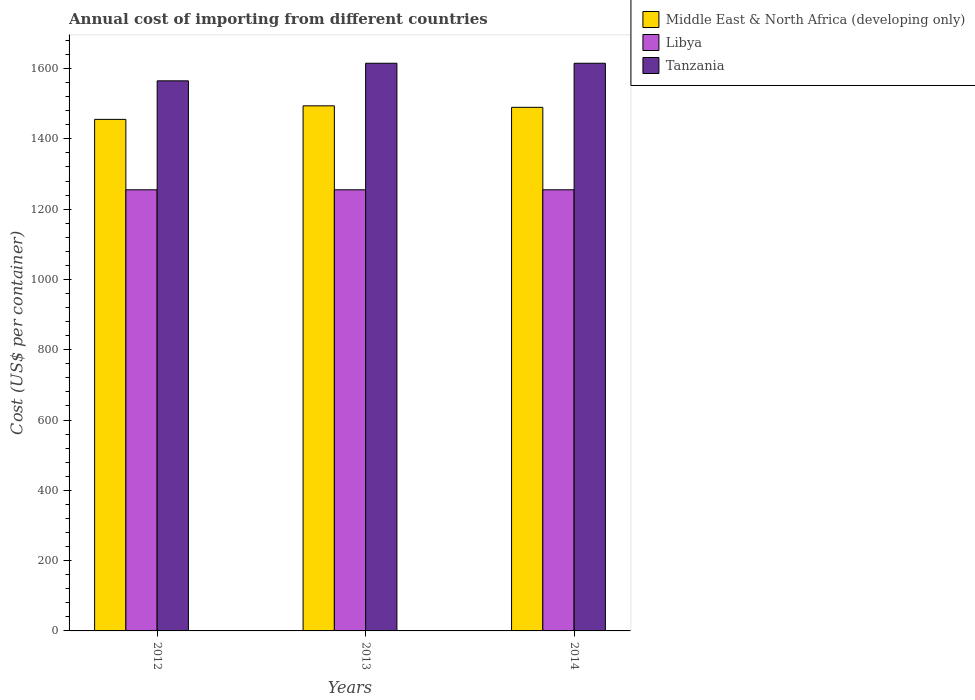How many different coloured bars are there?
Offer a very short reply. 3. How many groups of bars are there?
Make the answer very short. 3. How many bars are there on the 1st tick from the left?
Offer a terse response. 3. What is the total annual cost of importing in Middle East & North Africa (developing only) in 2014?
Ensure brevity in your answer.  1489.62. Across all years, what is the maximum total annual cost of importing in Libya?
Offer a very short reply. 1255. Across all years, what is the minimum total annual cost of importing in Middle East & North Africa (developing only)?
Your response must be concise. 1455.31. In which year was the total annual cost of importing in Tanzania maximum?
Your response must be concise. 2013. In which year was the total annual cost of importing in Tanzania minimum?
Offer a terse response. 2012. What is the total total annual cost of importing in Tanzania in the graph?
Make the answer very short. 4795. What is the difference between the total annual cost of importing in Middle East & North Africa (developing only) in 2012 and that in 2013?
Provide a succinct answer. -38.54. What is the difference between the total annual cost of importing in Middle East & North Africa (developing only) in 2014 and the total annual cost of importing in Libya in 2012?
Ensure brevity in your answer.  234.62. What is the average total annual cost of importing in Tanzania per year?
Your response must be concise. 1598.33. In the year 2013, what is the difference between the total annual cost of importing in Middle East & North Africa (developing only) and total annual cost of importing in Tanzania?
Your answer should be very brief. -121.15. What is the ratio of the total annual cost of importing in Libya in 2012 to that in 2013?
Offer a very short reply. 1. Is the difference between the total annual cost of importing in Middle East & North Africa (developing only) in 2012 and 2013 greater than the difference between the total annual cost of importing in Tanzania in 2012 and 2013?
Make the answer very short. Yes. What is the difference between the highest and the second highest total annual cost of importing in Middle East & North Africa (developing only)?
Provide a short and direct response. 4.23. What is the difference between the highest and the lowest total annual cost of importing in Tanzania?
Provide a succinct answer. 50. What does the 3rd bar from the left in 2014 represents?
Your answer should be compact. Tanzania. What does the 2nd bar from the right in 2014 represents?
Ensure brevity in your answer.  Libya. Is it the case that in every year, the sum of the total annual cost of importing in Libya and total annual cost of importing in Middle East & North Africa (developing only) is greater than the total annual cost of importing in Tanzania?
Your answer should be compact. Yes. How many bars are there?
Provide a short and direct response. 9. Are all the bars in the graph horizontal?
Make the answer very short. No. How many years are there in the graph?
Offer a terse response. 3. What is the difference between two consecutive major ticks on the Y-axis?
Offer a very short reply. 200. Does the graph contain grids?
Provide a succinct answer. No. Where does the legend appear in the graph?
Your response must be concise. Top right. How many legend labels are there?
Keep it short and to the point. 3. How are the legend labels stacked?
Provide a succinct answer. Vertical. What is the title of the graph?
Your answer should be compact. Annual cost of importing from different countries. Does "Arab World" appear as one of the legend labels in the graph?
Your response must be concise. No. What is the label or title of the X-axis?
Provide a succinct answer. Years. What is the label or title of the Y-axis?
Provide a succinct answer. Cost (US$ per container). What is the Cost (US$ per container) of Middle East & North Africa (developing only) in 2012?
Ensure brevity in your answer.  1455.31. What is the Cost (US$ per container) of Libya in 2012?
Offer a very short reply. 1255. What is the Cost (US$ per container) in Tanzania in 2012?
Offer a very short reply. 1565. What is the Cost (US$ per container) of Middle East & North Africa (developing only) in 2013?
Your answer should be compact. 1493.85. What is the Cost (US$ per container) in Libya in 2013?
Your response must be concise. 1255. What is the Cost (US$ per container) of Tanzania in 2013?
Ensure brevity in your answer.  1615. What is the Cost (US$ per container) in Middle East & North Africa (developing only) in 2014?
Your response must be concise. 1489.62. What is the Cost (US$ per container) of Libya in 2014?
Give a very brief answer. 1255. What is the Cost (US$ per container) in Tanzania in 2014?
Your answer should be compact. 1615. Across all years, what is the maximum Cost (US$ per container) of Middle East & North Africa (developing only)?
Offer a very short reply. 1493.85. Across all years, what is the maximum Cost (US$ per container) in Libya?
Give a very brief answer. 1255. Across all years, what is the maximum Cost (US$ per container) of Tanzania?
Offer a terse response. 1615. Across all years, what is the minimum Cost (US$ per container) of Middle East & North Africa (developing only)?
Ensure brevity in your answer.  1455.31. Across all years, what is the minimum Cost (US$ per container) of Libya?
Keep it short and to the point. 1255. Across all years, what is the minimum Cost (US$ per container) in Tanzania?
Give a very brief answer. 1565. What is the total Cost (US$ per container) in Middle East & North Africa (developing only) in the graph?
Provide a short and direct response. 4438.77. What is the total Cost (US$ per container) in Libya in the graph?
Your answer should be very brief. 3765. What is the total Cost (US$ per container) of Tanzania in the graph?
Offer a very short reply. 4795. What is the difference between the Cost (US$ per container) of Middle East & North Africa (developing only) in 2012 and that in 2013?
Keep it short and to the point. -38.54. What is the difference between the Cost (US$ per container) of Libya in 2012 and that in 2013?
Make the answer very short. 0. What is the difference between the Cost (US$ per container) of Tanzania in 2012 and that in 2013?
Keep it short and to the point. -50. What is the difference between the Cost (US$ per container) of Middle East & North Africa (developing only) in 2012 and that in 2014?
Keep it short and to the point. -34.31. What is the difference between the Cost (US$ per container) in Tanzania in 2012 and that in 2014?
Your answer should be compact. -50. What is the difference between the Cost (US$ per container) in Middle East & North Africa (developing only) in 2013 and that in 2014?
Make the answer very short. 4.23. What is the difference between the Cost (US$ per container) of Libya in 2013 and that in 2014?
Give a very brief answer. 0. What is the difference between the Cost (US$ per container) of Middle East & North Africa (developing only) in 2012 and the Cost (US$ per container) of Libya in 2013?
Give a very brief answer. 200.31. What is the difference between the Cost (US$ per container) in Middle East & North Africa (developing only) in 2012 and the Cost (US$ per container) in Tanzania in 2013?
Keep it short and to the point. -159.69. What is the difference between the Cost (US$ per container) of Libya in 2012 and the Cost (US$ per container) of Tanzania in 2013?
Your answer should be very brief. -360. What is the difference between the Cost (US$ per container) of Middle East & North Africa (developing only) in 2012 and the Cost (US$ per container) of Libya in 2014?
Your answer should be compact. 200.31. What is the difference between the Cost (US$ per container) in Middle East & North Africa (developing only) in 2012 and the Cost (US$ per container) in Tanzania in 2014?
Your answer should be very brief. -159.69. What is the difference between the Cost (US$ per container) in Libya in 2012 and the Cost (US$ per container) in Tanzania in 2014?
Offer a very short reply. -360. What is the difference between the Cost (US$ per container) of Middle East & North Africa (developing only) in 2013 and the Cost (US$ per container) of Libya in 2014?
Ensure brevity in your answer.  238.85. What is the difference between the Cost (US$ per container) in Middle East & North Africa (developing only) in 2013 and the Cost (US$ per container) in Tanzania in 2014?
Keep it short and to the point. -121.15. What is the difference between the Cost (US$ per container) in Libya in 2013 and the Cost (US$ per container) in Tanzania in 2014?
Make the answer very short. -360. What is the average Cost (US$ per container) in Middle East & North Africa (developing only) per year?
Provide a succinct answer. 1479.59. What is the average Cost (US$ per container) of Libya per year?
Keep it short and to the point. 1255. What is the average Cost (US$ per container) in Tanzania per year?
Your answer should be compact. 1598.33. In the year 2012, what is the difference between the Cost (US$ per container) of Middle East & North Africa (developing only) and Cost (US$ per container) of Libya?
Provide a succinct answer. 200.31. In the year 2012, what is the difference between the Cost (US$ per container) in Middle East & North Africa (developing only) and Cost (US$ per container) in Tanzania?
Your response must be concise. -109.69. In the year 2012, what is the difference between the Cost (US$ per container) in Libya and Cost (US$ per container) in Tanzania?
Provide a succinct answer. -310. In the year 2013, what is the difference between the Cost (US$ per container) of Middle East & North Africa (developing only) and Cost (US$ per container) of Libya?
Ensure brevity in your answer.  238.85. In the year 2013, what is the difference between the Cost (US$ per container) in Middle East & North Africa (developing only) and Cost (US$ per container) in Tanzania?
Offer a terse response. -121.15. In the year 2013, what is the difference between the Cost (US$ per container) in Libya and Cost (US$ per container) in Tanzania?
Your answer should be compact. -360. In the year 2014, what is the difference between the Cost (US$ per container) in Middle East & North Africa (developing only) and Cost (US$ per container) in Libya?
Your response must be concise. 234.62. In the year 2014, what is the difference between the Cost (US$ per container) of Middle East & North Africa (developing only) and Cost (US$ per container) of Tanzania?
Your answer should be compact. -125.38. In the year 2014, what is the difference between the Cost (US$ per container) of Libya and Cost (US$ per container) of Tanzania?
Ensure brevity in your answer.  -360. What is the ratio of the Cost (US$ per container) of Middle East & North Africa (developing only) in 2012 to that in 2013?
Keep it short and to the point. 0.97. What is the ratio of the Cost (US$ per container) of Tanzania in 2012 to that in 2013?
Your answer should be compact. 0.97. What is the ratio of the Cost (US$ per container) of Libya in 2012 to that in 2014?
Your answer should be compact. 1. What is the ratio of the Cost (US$ per container) of Tanzania in 2012 to that in 2014?
Keep it short and to the point. 0.97. What is the ratio of the Cost (US$ per container) of Libya in 2013 to that in 2014?
Provide a succinct answer. 1. What is the ratio of the Cost (US$ per container) of Tanzania in 2013 to that in 2014?
Give a very brief answer. 1. What is the difference between the highest and the second highest Cost (US$ per container) of Middle East & North Africa (developing only)?
Your answer should be compact. 4.23. What is the difference between the highest and the second highest Cost (US$ per container) in Tanzania?
Your response must be concise. 0. What is the difference between the highest and the lowest Cost (US$ per container) in Middle East & North Africa (developing only)?
Your answer should be very brief. 38.54. What is the difference between the highest and the lowest Cost (US$ per container) of Tanzania?
Offer a terse response. 50. 